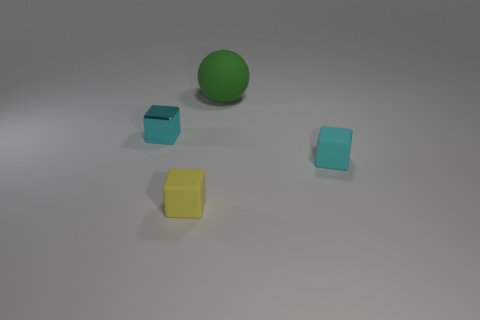What materials do the objects in the image seem to be made of? The objects in the image appear to be made of different materials. The green spherical object looks like it could be made of rubber or plastic, while the blue and yellow objects seem to have a metallic finish, suggesting they could be made of metal. 